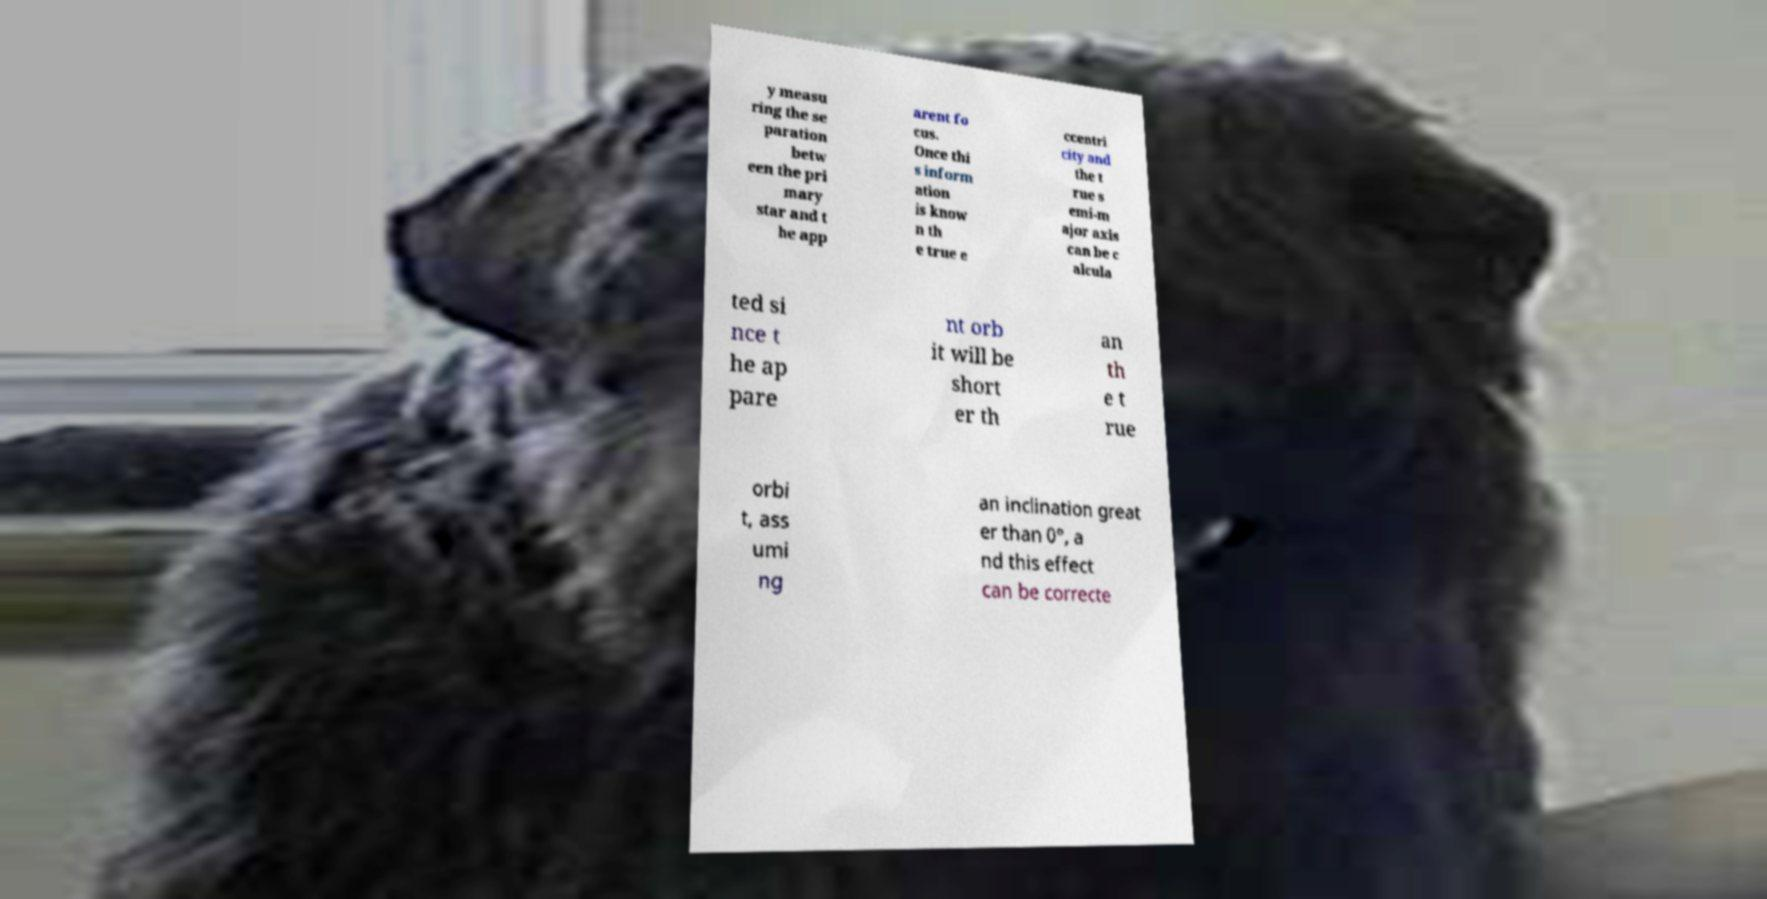Please identify and transcribe the text found in this image. y measu ring the se paration betw een the pri mary star and t he app arent fo cus. Once thi s inform ation is know n th e true e ccentri city and the t rue s emi-m ajor axis can be c alcula ted si nce t he ap pare nt orb it will be short er th an th e t rue orbi t, ass umi ng an inclination great er than 0°, a nd this effect can be correcte 